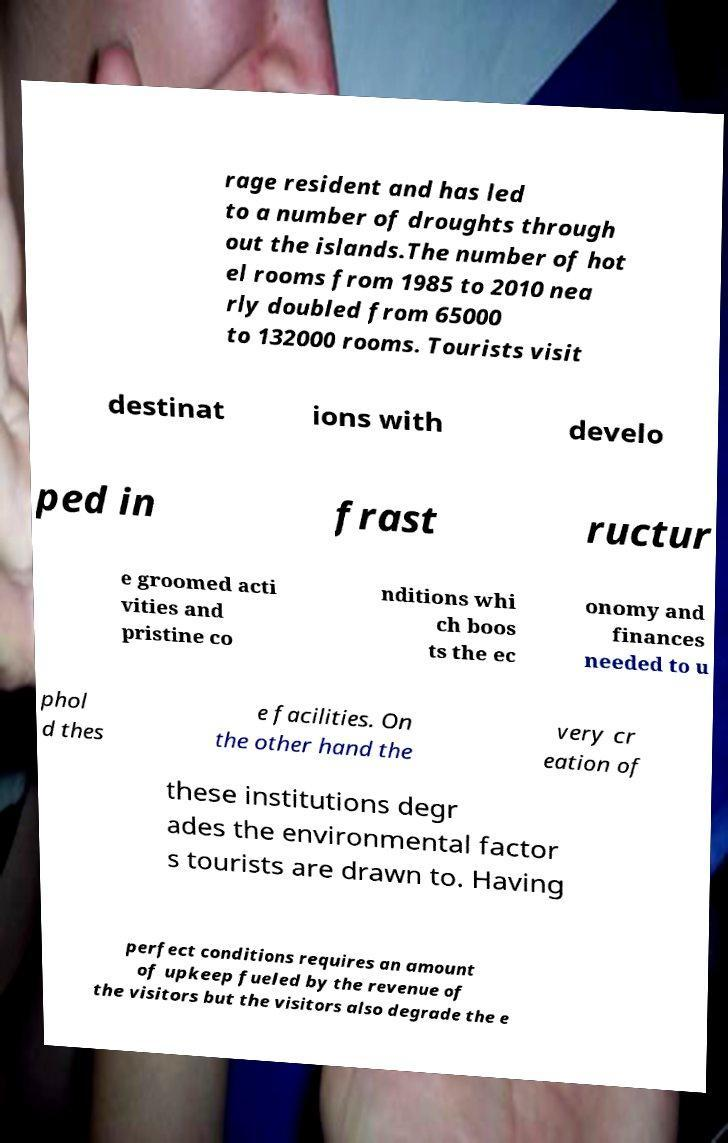Please identify and transcribe the text found in this image. rage resident and has led to a number of droughts through out the islands.The number of hot el rooms from 1985 to 2010 nea rly doubled from 65000 to 132000 rooms. Tourists visit destinat ions with develo ped in frast ructur e groomed acti vities and pristine co nditions whi ch boos ts the ec onomy and finances needed to u phol d thes e facilities. On the other hand the very cr eation of these institutions degr ades the environmental factor s tourists are drawn to. Having perfect conditions requires an amount of upkeep fueled by the revenue of the visitors but the visitors also degrade the e 